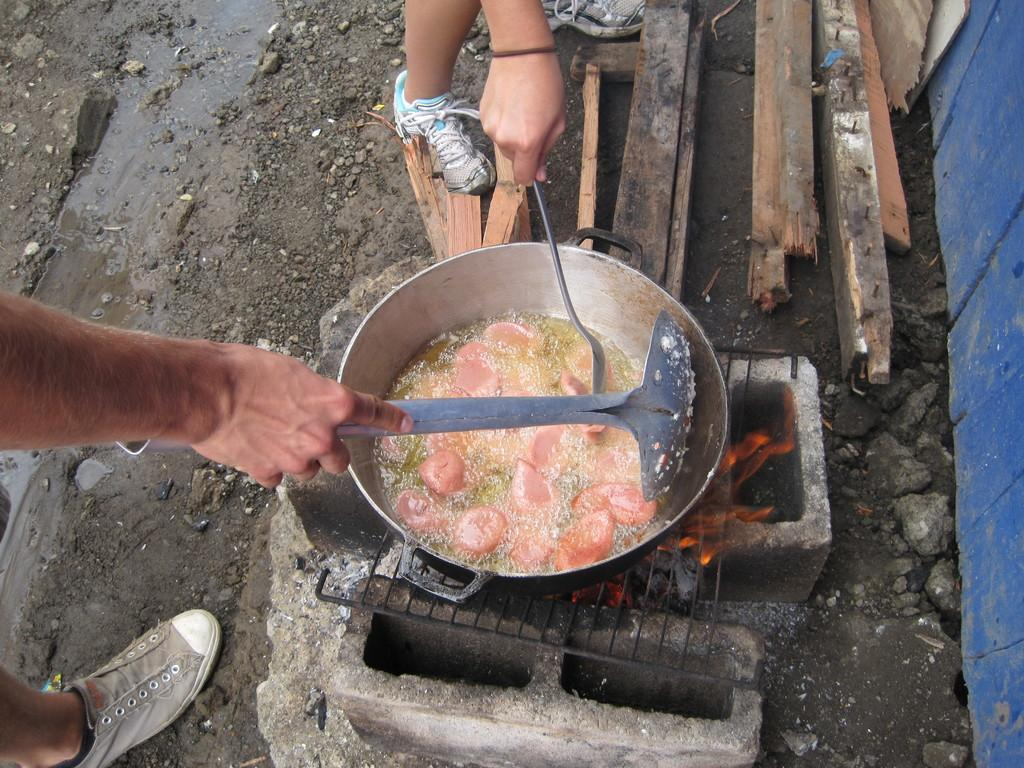How many people are in the image? There are two persons in the image. What is happening in the image? There is fire in the image, and it appears to be related to cooking, as there is a grill, a pan, oil, and food present. What is the source of the fire in the image? The fire is likely coming from the grill, as it is the primary heat source in the image. What type of fuel is being used for the fire? Wood is visible in the image, which suggests it might be the fuel source for the fire. What type of tax is being discussed by the army in the image? There is no army or discussion of taxes present in the image. Is there a fireman present in the image? No, there is no fireman present in the image. 